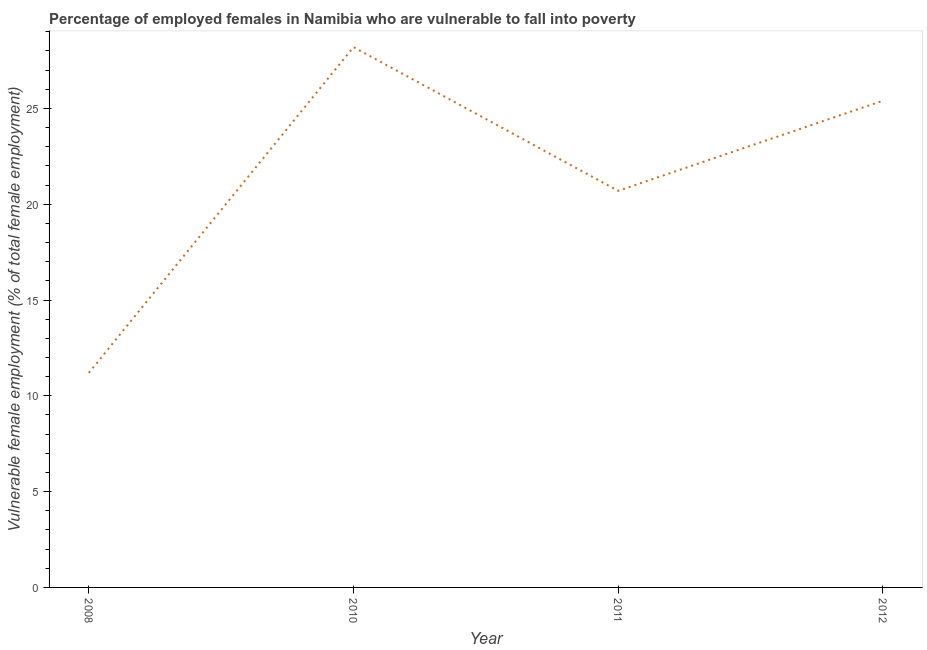What is the percentage of employed females who are vulnerable to fall into poverty in 2012?
Offer a very short reply. 25.4. Across all years, what is the maximum percentage of employed females who are vulnerable to fall into poverty?
Give a very brief answer. 28.2. Across all years, what is the minimum percentage of employed females who are vulnerable to fall into poverty?
Provide a short and direct response. 11.2. In which year was the percentage of employed females who are vulnerable to fall into poverty minimum?
Give a very brief answer. 2008. What is the sum of the percentage of employed females who are vulnerable to fall into poverty?
Provide a short and direct response. 85.5. What is the difference between the percentage of employed females who are vulnerable to fall into poverty in 2008 and 2011?
Your response must be concise. -9.5. What is the average percentage of employed females who are vulnerable to fall into poverty per year?
Provide a succinct answer. 21.38. What is the median percentage of employed females who are vulnerable to fall into poverty?
Make the answer very short. 23.05. In how many years, is the percentage of employed females who are vulnerable to fall into poverty greater than 24 %?
Offer a terse response. 2. What is the ratio of the percentage of employed females who are vulnerable to fall into poverty in 2010 to that in 2011?
Offer a terse response. 1.36. Is the difference between the percentage of employed females who are vulnerable to fall into poverty in 2008 and 2012 greater than the difference between any two years?
Keep it short and to the point. No. What is the difference between the highest and the second highest percentage of employed females who are vulnerable to fall into poverty?
Make the answer very short. 2.8. What is the difference between the highest and the lowest percentage of employed females who are vulnerable to fall into poverty?
Make the answer very short. 17. In how many years, is the percentage of employed females who are vulnerable to fall into poverty greater than the average percentage of employed females who are vulnerable to fall into poverty taken over all years?
Offer a terse response. 2. How many lines are there?
Your answer should be very brief. 1. Does the graph contain any zero values?
Offer a terse response. No. Does the graph contain grids?
Your answer should be compact. No. What is the title of the graph?
Provide a succinct answer. Percentage of employed females in Namibia who are vulnerable to fall into poverty. What is the label or title of the Y-axis?
Offer a very short reply. Vulnerable female employment (% of total female employment). What is the Vulnerable female employment (% of total female employment) of 2008?
Make the answer very short. 11.2. What is the Vulnerable female employment (% of total female employment) in 2010?
Your answer should be compact. 28.2. What is the Vulnerable female employment (% of total female employment) in 2011?
Your response must be concise. 20.7. What is the Vulnerable female employment (% of total female employment) of 2012?
Your answer should be compact. 25.4. What is the difference between the Vulnerable female employment (% of total female employment) in 2008 and 2011?
Make the answer very short. -9.5. What is the difference between the Vulnerable female employment (% of total female employment) in 2008 and 2012?
Offer a terse response. -14.2. What is the difference between the Vulnerable female employment (% of total female employment) in 2010 and 2011?
Provide a short and direct response. 7.5. What is the difference between the Vulnerable female employment (% of total female employment) in 2010 and 2012?
Offer a terse response. 2.8. What is the ratio of the Vulnerable female employment (% of total female employment) in 2008 to that in 2010?
Offer a very short reply. 0.4. What is the ratio of the Vulnerable female employment (% of total female employment) in 2008 to that in 2011?
Offer a very short reply. 0.54. What is the ratio of the Vulnerable female employment (% of total female employment) in 2008 to that in 2012?
Keep it short and to the point. 0.44. What is the ratio of the Vulnerable female employment (% of total female employment) in 2010 to that in 2011?
Keep it short and to the point. 1.36. What is the ratio of the Vulnerable female employment (% of total female employment) in 2010 to that in 2012?
Your response must be concise. 1.11. What is the ratio of the Vulnerable female employment (% of total female employment) in 2011 to that in 2012?
Your answer should be compact. 0.81. 